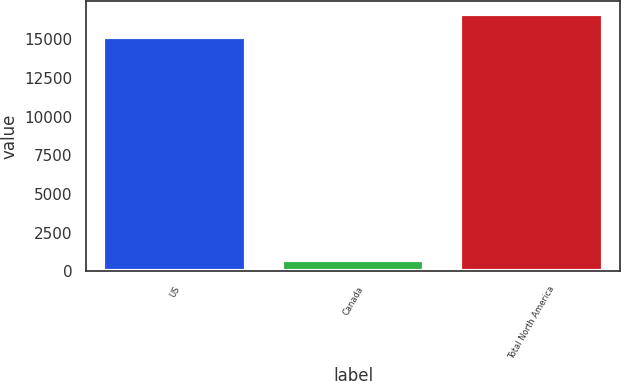<chart> <loc_0><loc_0><loc_500><loc_500><bar_chart><fcel>US<fcel>Canada<fcel>Total North America<nl><fcel>15130<fcel>698<fcel>16643<nl></chart> 